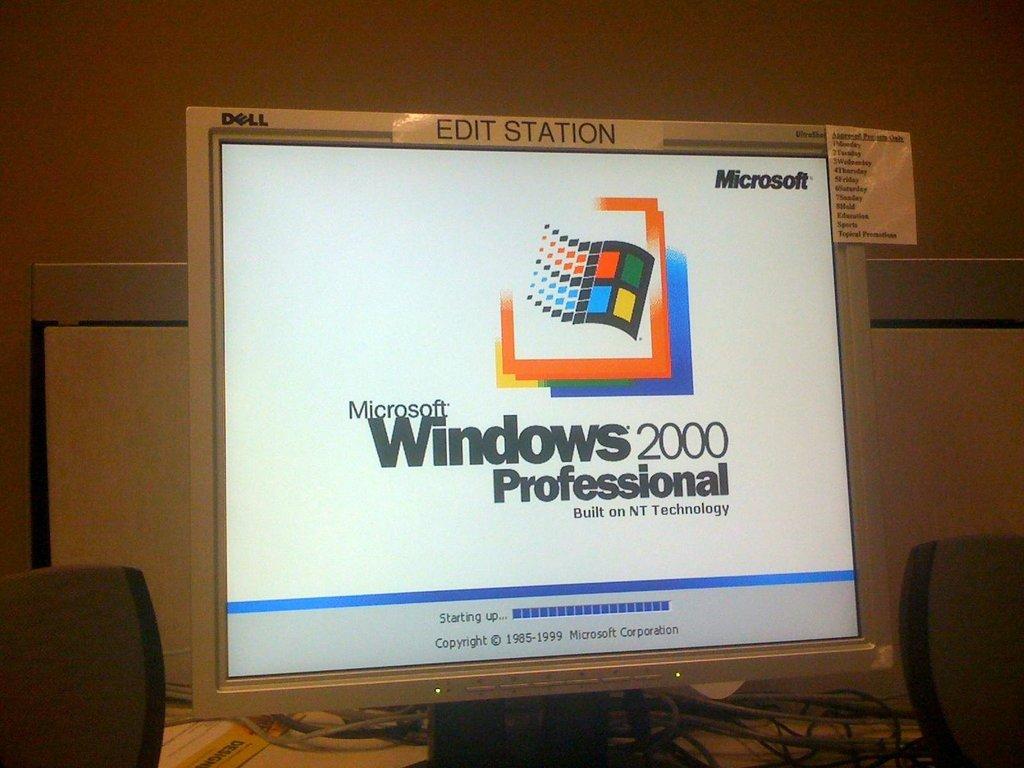What version of windows is on this computer?
Your answer should be compact. 2000 professional. What company is the copyright for at the bottom of the screen?
Make the answer very short. Microsoft. 